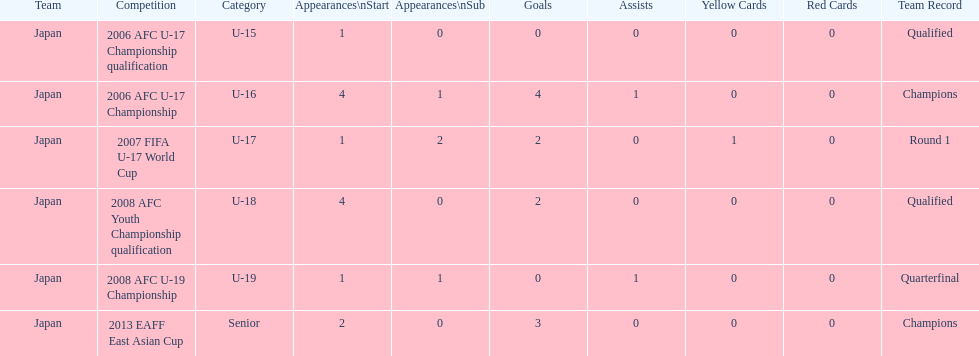Write the full table. {'header': ['Team', 'Competition', 'Category', 'Appearances\\nStart', 'Appearances\\nSub', 'Goals', 'Assists', 'Yellow Cards', 'Red Cards', 'Team Record'], 'rows': [['Japan', '2006 AFC U-17 Championship qualification', 'U-15', '1', '0', '0', '0', '0', '0', 'Qualified'], ['Japan', '2006 AFC U-17 Championship', 'U-16', '4', '1', '4', '1', '0', '0', 'Champions'], ['Japan', '2007 FIFA U-17 World Cup', 'U-17', '1', '2', '2', '0', '1', '0', 'Round 1'], ['Japan', '2008 AFC Youth Championship qualification', 'U-18', '4', '0', '2', '0', '0', '0', 'Qualified'], ['Japan', '2008 AFC U-19 Championship', 'U-19', '1', '1', '0', '1', '0', '0', 'Quarterfinal'], ['Japan', '2013 EAFF East Asian Cup', 'Senior', '2', '0', '3', '0', '0', '0', 'Champions']]} Name the earliest competition to have a sub. 2006 AFC U-17 Championship. 